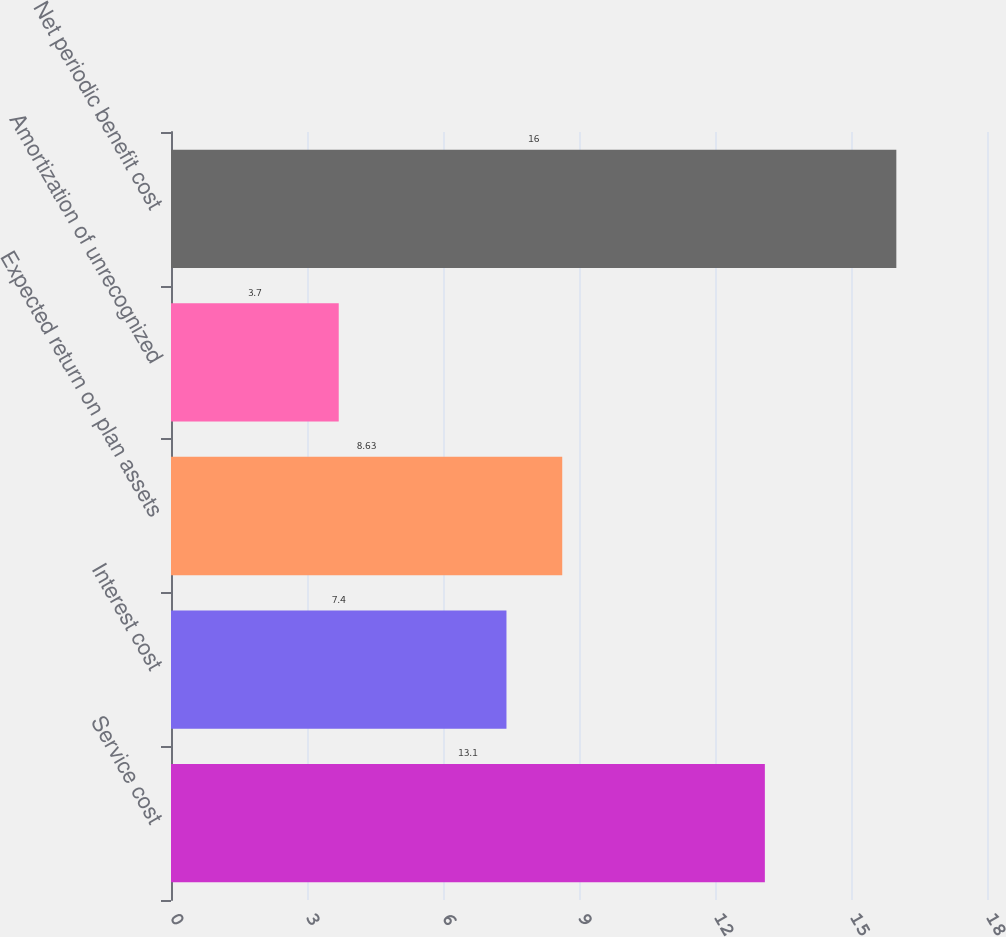Convert chart. <chart><loc_0><loc_0><loc_500><loc_500><bar_chart><fcel>Service cost<fcel>Interest cost<fcel>Expected return on plan assets<fcel>Amortization of unrecognized<fcel>Net periodic benefit cost<nl><fcel>13.1<fcel>7.4<fcel>8.63<fcel>3.7<fcel>16<nl></chart> 